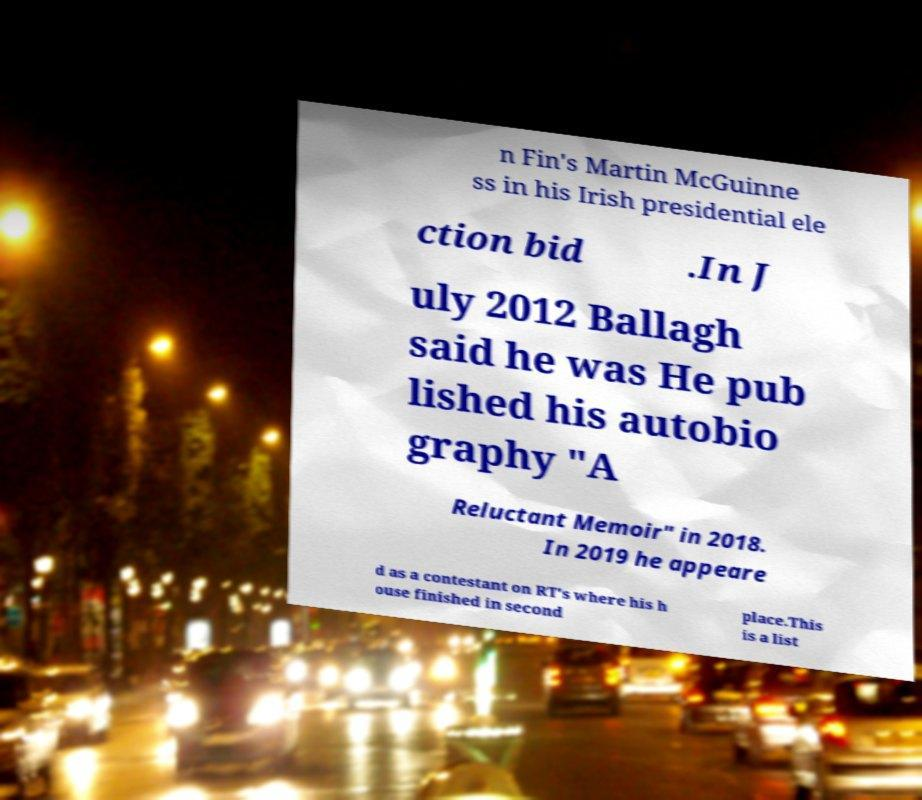What messages or text are displayed in this image? I need them in a readable, typed format. n Fin's Martin McGuinne ss in his Irish presidential ele ction bid .In J uly 2012 Ballagh said he was He pub lished his autobio graphy "A Reluctant Memoir" in 2018. In 2019 he appeare d as a contestant on RT's where his h ouse finished in second place.This is a list 